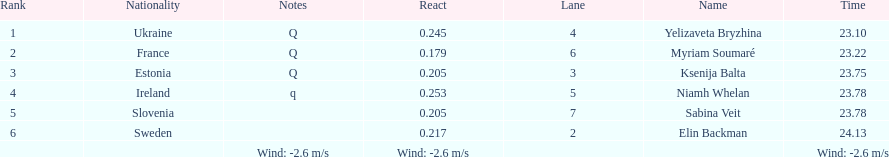Whose time is more than. 24.00? Elin Backman. 